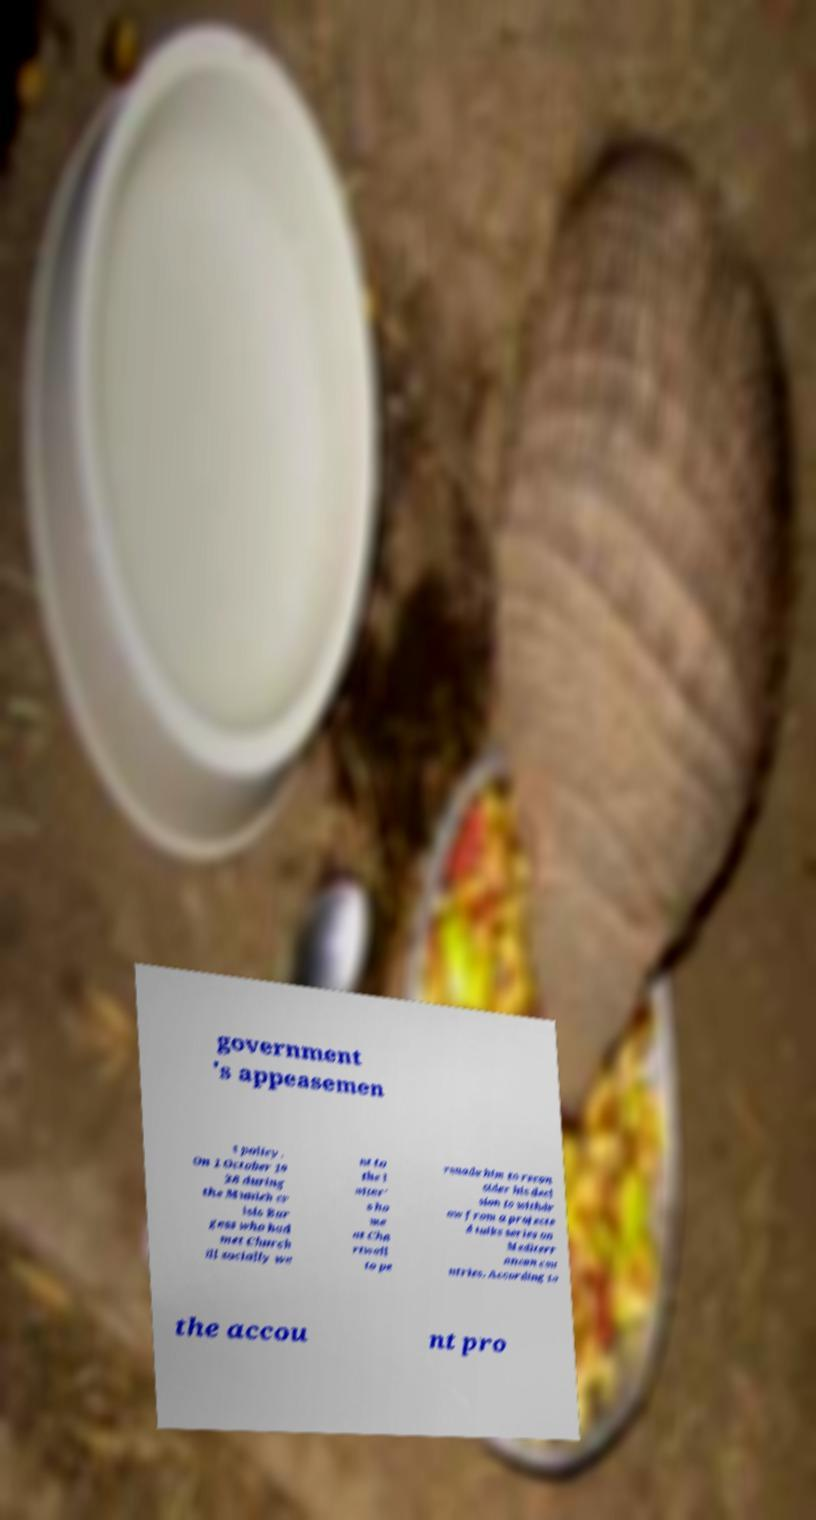Can you accurately transcribe the text from the provided image for me? government 's appeasemen t policy. On 1 October 19 38 during the Munich cr isis Bur gess who had met Church ill socially we nt to the l atter' s ho me at Cha rtwell to pe rsuade him to recon sider his deci sion to withdr aw from a projecte d talks series on Mediterr anean cou ntries. According to the accou nt pro 